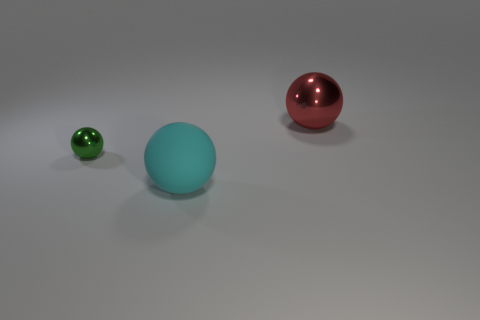Subtract all tiny green metallic balls. How many balls are left? 2 Add 2 large red metallic objects. How many objects exist? 5 Subtract all red spheres. How many spheres are left? 2 Subtract 2 balls. How many balls are left? 1 Subtract all cyan balls. Subtract all yellow cylinders. How many balls are left? 2 Subtract all yellow cubes. How many purple balls are left? 0 Subtract all red matte cylinders. Subtract all big metallic spheres. How many objects are left? 2 Add 2 large red spheres. How many large red spheres are left? 3 Add 3 large blocks. How many large blocks exist? 3 Subtract 0 cyan blocks. How many objects are left? 3 